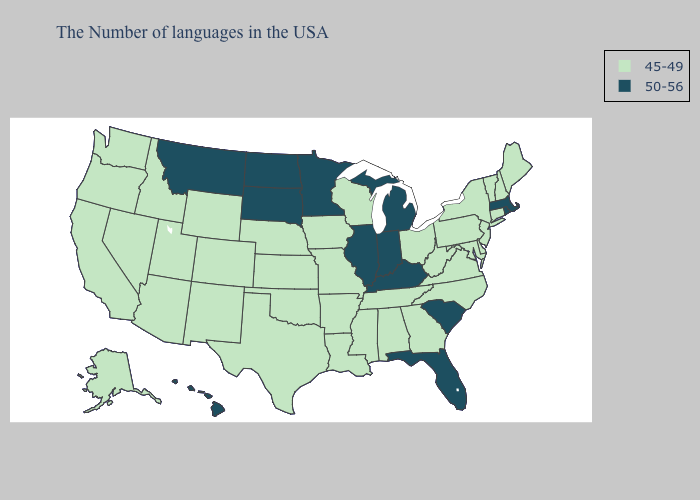Which states have the lowest value in the Northeast?
Write a very short answer. Maine, New Hampshire, Vermont, Connecticut, New York, New Jersey, Pennsylvania. Does Pennsylvania have the lowest value in the Northeast?
Answer briefly. Yes. Does Rhode Island have the highest value in the Northeast?
Short answer required. Yes. Does Florida have the same value as South Carolina?
Short answer required. Yes. What is the lowest value in the MidWest?
Give a very brief answer. 45-49. Does Nebraska have the lowest value in the USA?
Answer briefly. Yes. Which states have the highest value in the USA?
Quick response, please. Massachusetts, Rhode Island, South Carolina, Florida, Michigan, Kentucky, Indiana, Illinois, Minnesota, South Dakota, North Dakota, Montana, Hawaii. Name the states that have a value in the range 45-49?
Keep it brief. Maine, New Hampshire, Vermont, Connecticut, New York, New Jersey, Delaware, Maryland, Pennsylvania, Virginia, North Carolina, West Virginia, Ohio, Georgia, Alabama, Tennessee, Wisconsin, Mississippi, Louisiana, Missouri, Arkansas, Iowa, Kansas, Nebraska, Oklahoma, Texas, Wyoming, Colorado, New Mexico, Utah, Arizona, Idaho, Nevada, California, Washington, Oregon, Alaska. What is the value of North Carolina?
Answer briefly. 45-49. Does California have the lowest value in the West?
Write a very short answer. Yes. What is the highest value in the USA?
Be succinct. 50-56. Which states have the lowest value in the USA?
Write a very short answer. Maine, New Hampshire, Vermont, Connecticut, New York, New Jersey, Delaware, Maryland, Pennsylvania, Virginia, North Carolina, West Virginia, Ohio, Georgia, Alabama, Tennessee, Wisconsin, Mississippi, Louisiana, Missouri, Arkansas, Iowa, Kansas, Nebraska, Oklahoma, Texas, Wyoming, Colorado, New Mexico, Utah, Arizona, Idaho, Nevada, California, Washington, Oregon, Alaska. Which states have the lowest value in the South?
Short answer required. Delaware, Maryland, Virginia, North Carolina, West Virginia, Georgia, Alabama, Tennessee, Mississippi, Louisiana, Arkansas, Oklahoma, Texas. Does Nebraska have the same value as Rhode Island?
Give a very brief answer. No. Is the legend a continuous bar?
Write a very short answer. No. 